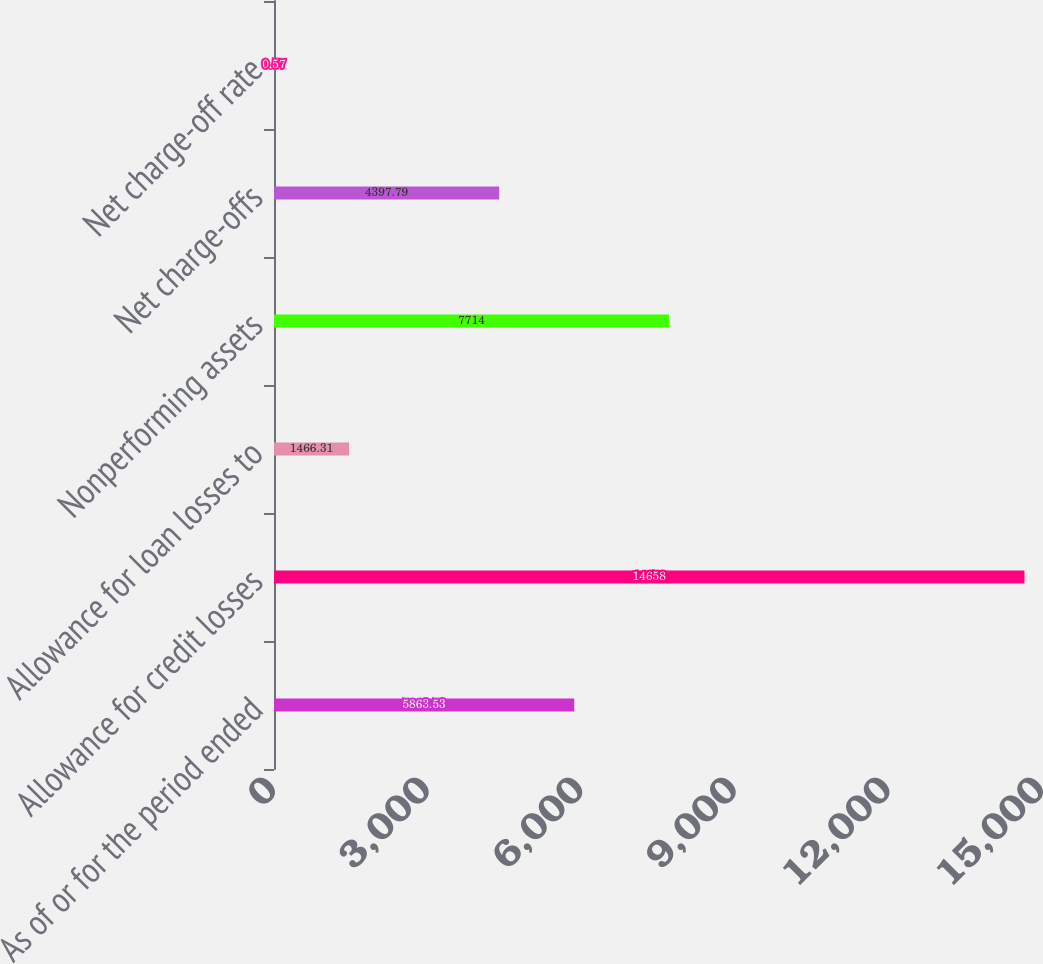Convert chart. <chart><loc_0><loc_0><loc_500><loc_500><bar_chart><fcel>As of or for the period ended<fcel>Allowance for credit losses<fcel>Allowance for loan losses to<fcel>Nonperforming assets<fcel>Net charge-offs<fcel>Net charge-off rate<nl><fcel>5863.53<fcel>14658<fcel>1466.31<fcel>7714<fcel>4397.79<fcel>0.57<nl></chart> 